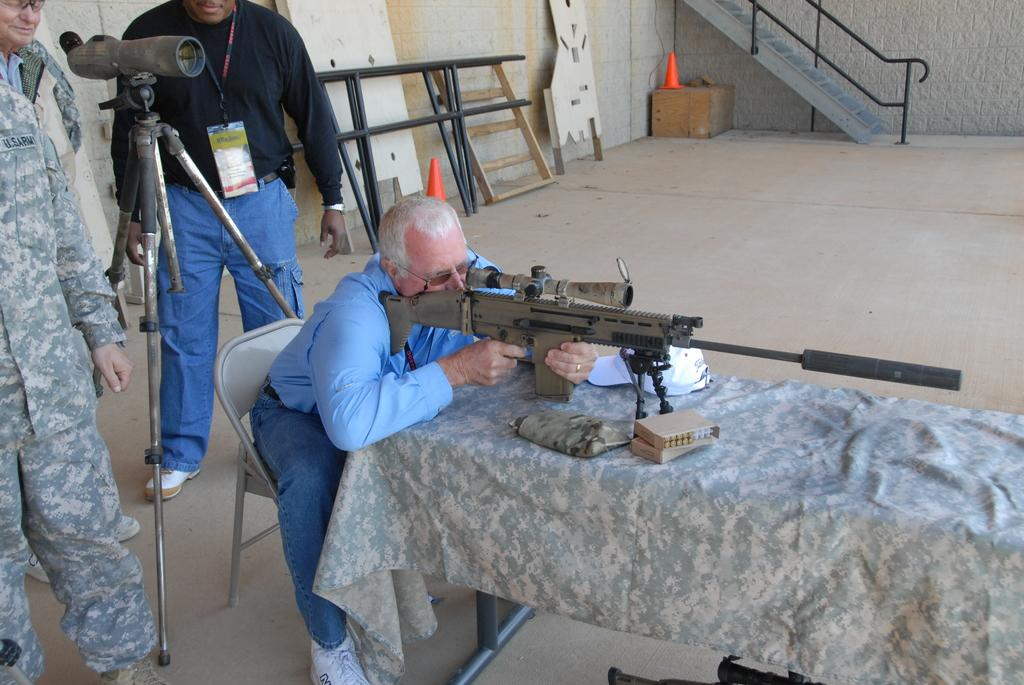What type of structure is present in the image? There are stairs in the image. What piece of furniture can be seen in the image? There is a table in the image. What objects are on the table? There are bullets and a gun on the table. Who is holding the gun in the image? A person is holding the gun. Where are the other persons located in the image? The other persons are on the left side of the image. What type of statement is being made by the person holding the gun in the image? There is no indication of a statement being made in the image; it only shows a person holding a gun and other objects on a table. What type of hook is present in the image? There is no hook present in the image. 